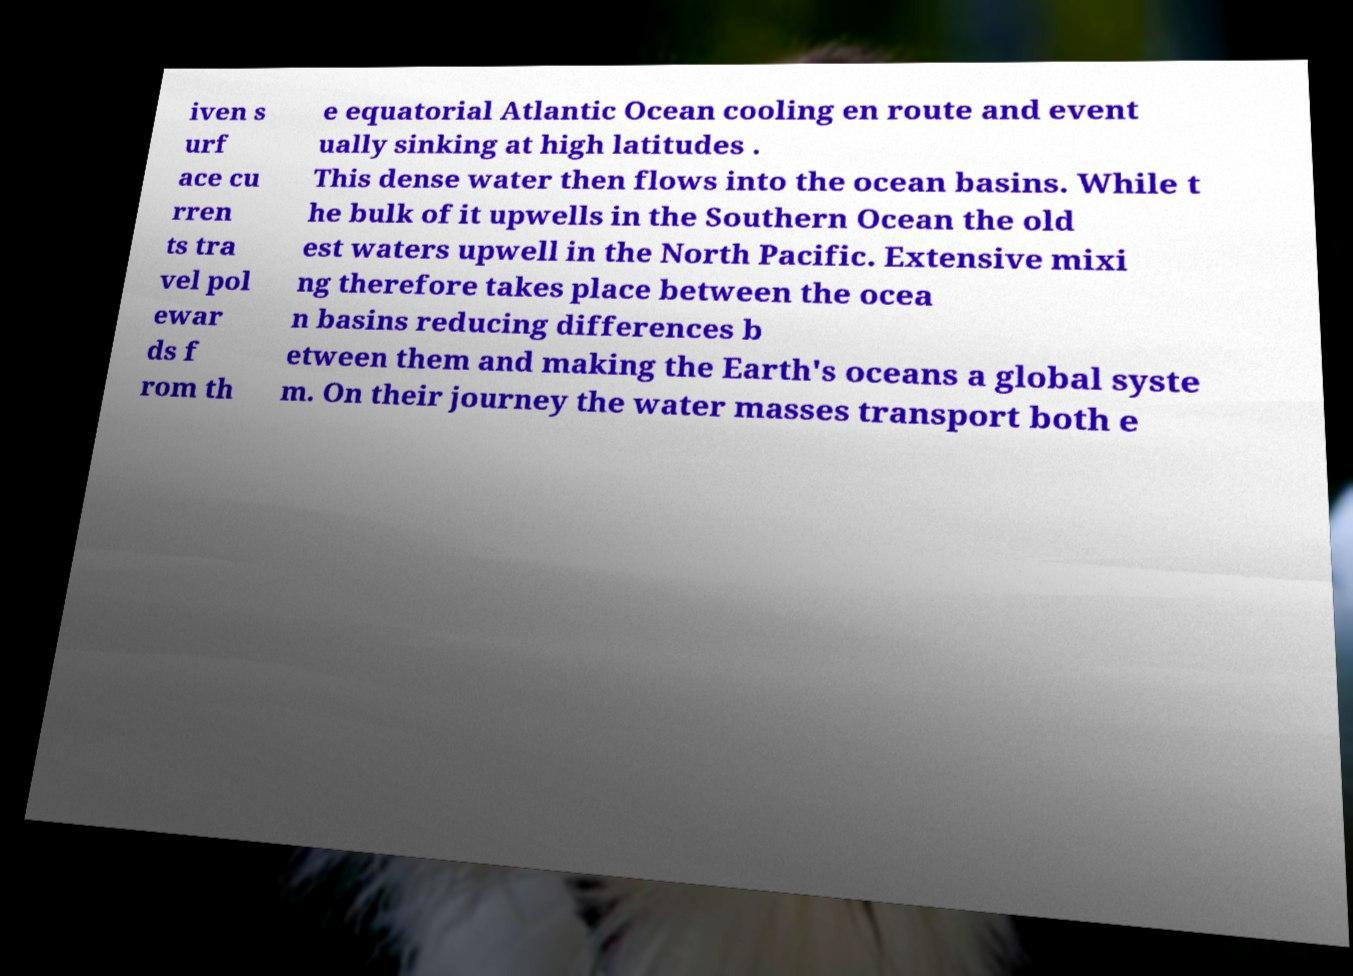Can you read and provide the text displayed in the image?This photo seems to have some interesting text. Can you extract and type it out for me? iven s urf ace cu rren ts tra vel pol ewar ds f rom th e equatorial Atlantic Ocean cooling en route and event ually sinking at high latitudes . This dense water then flows into the ocean basins. While t he bulk of it upwells in the Southern Ocean the old est waters upwell in the North Pacific. Extensive mixi ng therefore takes place between the ocea n basins reducing differences b etween them and making the Earth's oceans a global syste m. On their journey the water masses transport both e 